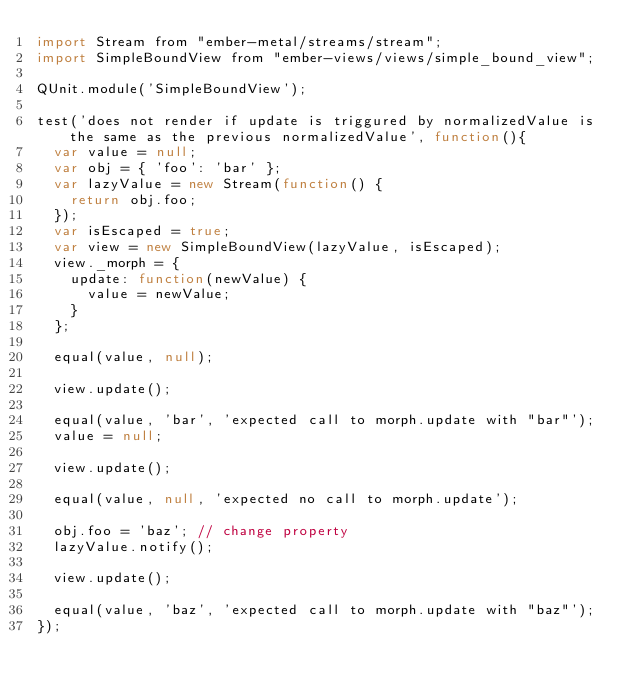<code> <loc_0><loc_0><loc_500><loc_500><_JavaScript_>import Stream from "ember-metal/streams/stream";
import SimpleBoundView from "ember-views/views/simple_bound_view";

QUnit.module('SimpleBoundView');

test('does not render if update is triggured by normalizedValue is the same as the previous normalizedValue', function(){
  var value = null;
  var obj = { 'foo': 'bar' };
  var lazyValue = new Stream(function() {
    return obj.foo;
  });
  var isEscaped = true;
  var view = new SimpleBoundView(lazyValue, isEscaped);
  view._morph = {
    update: function(newValue) {
      value = newValue;
    }
  };

  equal(value, null);

  view.update();

  equal(value, 'bar', 'expected call to morph.update with "bar"');
  value = null;

  view.update();

  equal(value, null, 'expected no call to morph.update');

  obj.foo = 'baz'; // change property
  lazyValue.notify();

  view.update();

  equal(value, 'baz', 'expected call to morph.update with "baz"');
});
</code> 